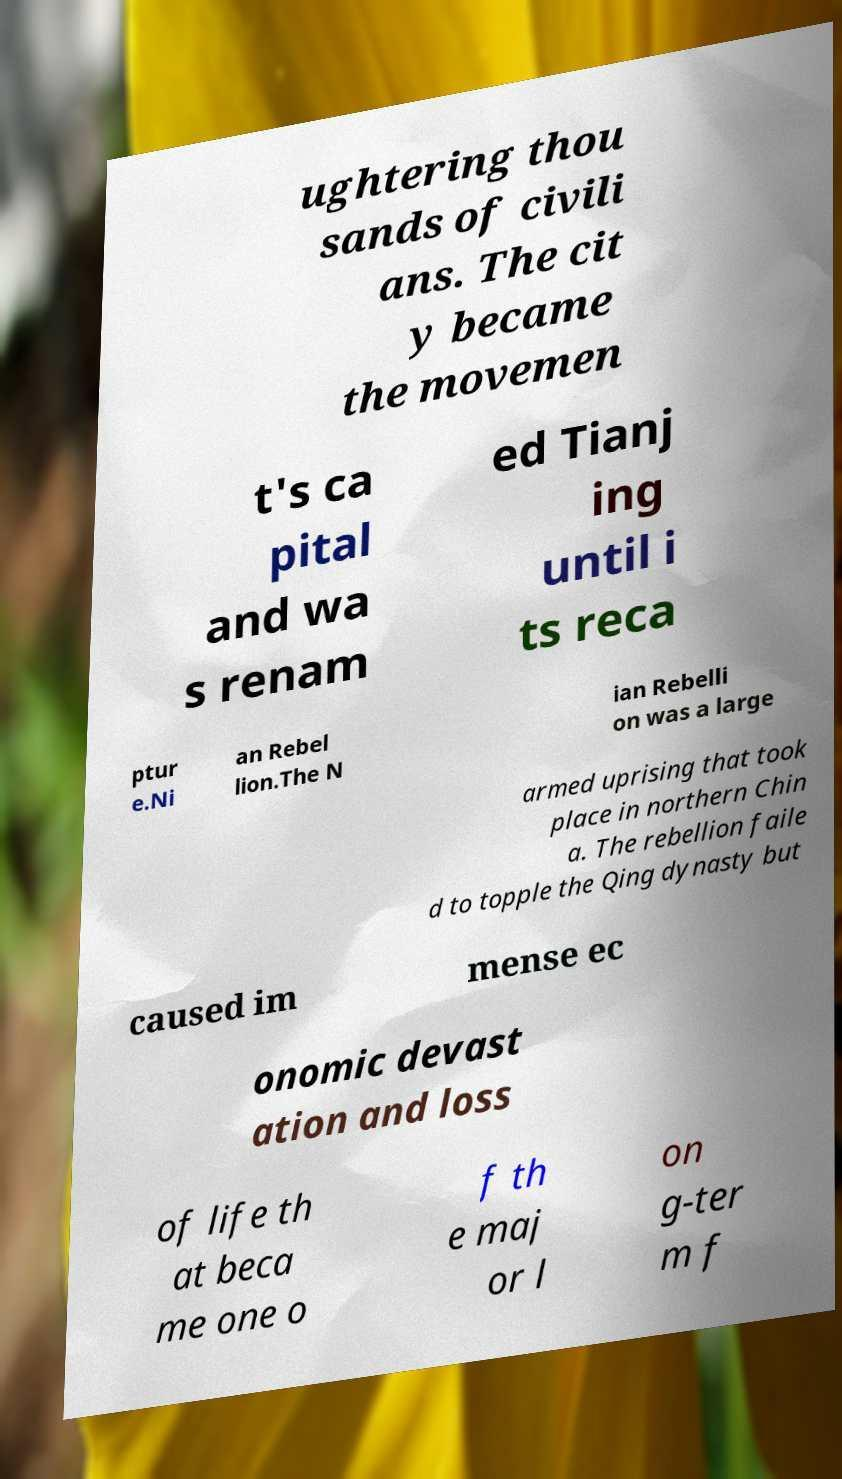I need the written content from this picture converted into text. Can you do that? ughtering thou sands of civili ans. The cit y became the movemen t's ca pital and wa s renam ed Tianj ing until i ts reca ptur e.Ni an Rebel lion.The N ian Rebelli on was a large armed uprising that took place in northern Chin a. The rebellion faile d to topple the Qing dynasty but caused im mense ec onomic devast ation and loss of life th at beca me one o f th e maj or l on g-ter m f 